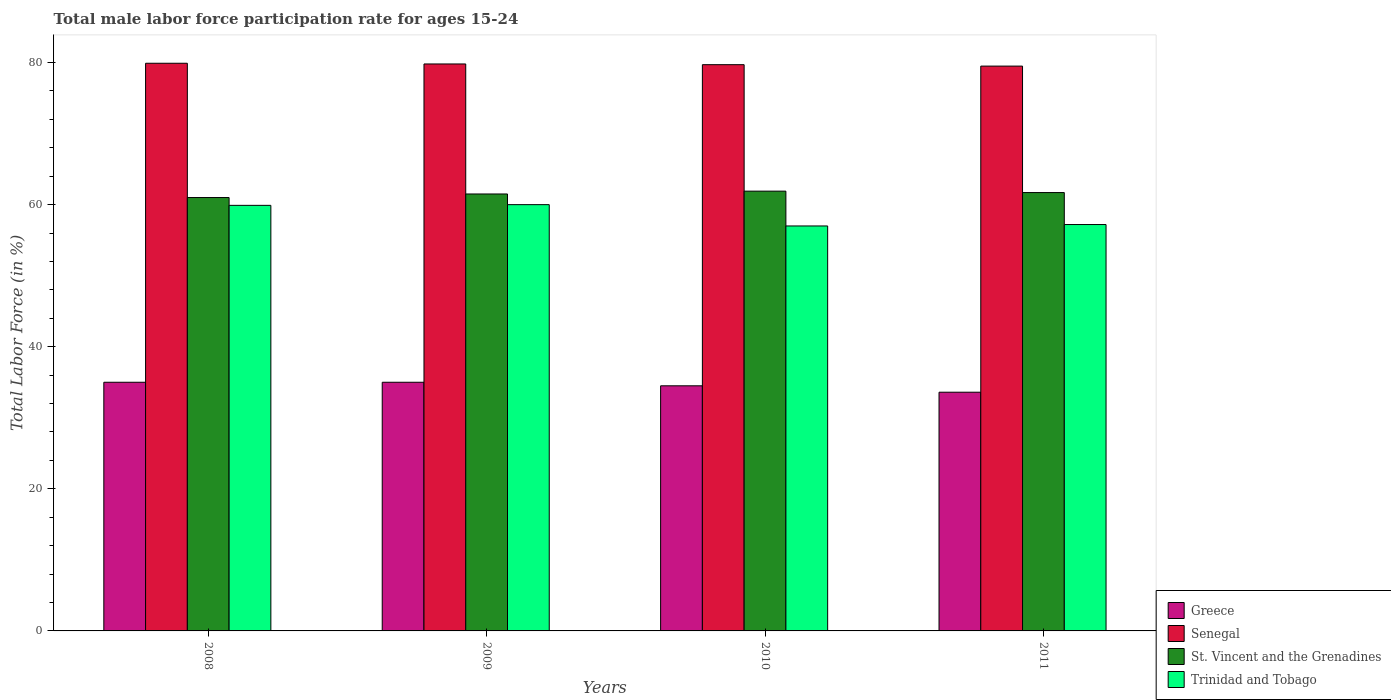How many different coloured bars are there?
Give a very brief answer. 4. Are the number of bars per tick equal to the number of legend labels?
Make the answer very short. Yes. How many bars are there on the 3rd tick from the left?
Ensure brevity in your answer.  4. What is the male labor force participation rate in St. Vincent and the Grenadines in 2011?
Offer a terse response. 61.7. Across all years, what is the maximum male labor force participation rate in Trinidad and Tobago?
Keep it short and to the point. 60. In which year was the male labor force participation rate in Trinidad and Tobago maximum?
Give a very brief answer. 2009. What is the total male labor force participation rate in Senegal in the graph?
Your answer should be very brief. 318.9. What is the difference between the male labor force participation rate in Senegal in 2010 and that in 2011?
Give a very brief answer. 0.2. What is the average male labor force participation rate in Trinidad and Tobago per year?
Ensure brevity in your answer.  58.53. In how many years, is the male labor force participation rate in St. Vincent and the Grenadines greater than 76 %?
Your answer should be very brief. 0. What is the ratio of the male labor force participation rate in Trinidad and Tobago in 2010 to that in 2011?
Give a very brief answer. 1. What is the difference between the highest and the second highest male labor force participation rate in Trinidad and Tobago?
Make the answer very short. 0.1. What is the difference between the highest and the lowest male labor force participation rate in Greece?
Ensure brevity in your answer.  1.4. In how many years, is the male labor force participation rate in St. Vincent and the Grenadines greater than the average male labor force participation rate in St. Vincent and the Grenadines taken over all years?
Your answer should be very brief. 2. Is the sum of the male labor force participation rate in Trinidad and Tobago in 2008 and 2009 greater than the maximum male labor force participation rate in Greece across all years?
Provide a succinct answer. Yes. Is it the case that in every year, the sum of the male labor force participation rate in St. Vincent and the Grenadines and male labor force participation rate in Senegal is greater than the sum of male labor force participation rate in Trinidad and Tobago and male labor force participation rate in Greece?
Provide a short and direct response. Yes. What does the 3rd bar from the left in 2009 represents?
Your answer should be very brief. St. Vincent and the Grenadines. What does the 1st bar from the right in 2010 represents?
Make the answer very short. Trinidad and Tobago. Is it the case that in every year, the sum of the male labor force participation rate in Senegal and male labor force participation rate in Greece is greater than the male labor force participation rate in St. Vincent and the Grenadines?
Offer a very short reply. Yes. How many bars are there?
Provide a succinct answer. 16. How many years are there in the graph?
Your answer should be very brief. 4. What is the difference between two consecutive major ticks on the Y-axis?
Offer a terse response. 20. What is the title of the graph?
Offer a terse response. Total male labor force participation rate for ages 15-24. What is the label or title of the Y-axis?
Provide a succinct answer. Total Labor Force (in %). What is the Total Labor Force (in %) of Greece in 2008?
Your answer should be very brief. 35. What is the Total Labor Force (in %) of Senegal in 2008?
Provide a succinct answer. 79.9. What is the Total Labor Force (in %) in St. Vincent and the Grenadines in 2008?
Keep it short and to the point. 61. What is the Total Labor Force (in %) in Trinidad and Tobago in 2008?
Make the answer very short. 59.9. What is the Total Labor Force (in %) in Senegal in 2009?
Your answer should be compact. 79.8. What is the Total Labor Force (in %) in St. Vincent and the Grenadines in 2009?
Ensure brevity in your answer.  61.5. What is the Total Labor Force (in %) of Greece in 2010?
Give a very brief answer. 34.5. What is the Total Labor Force (in %) in Senegal in 2010?
Make the answer very short. 79.7. What is the Total Labor Force (in %) of St. Vincent and the Grenadines in 2010?
Offer a terse response. 61.9. What is the Total Labor Force (in %) of Greece in 2011?
Offer a terse response. 33.6. What is the Total Labor Force (in %) of Senegal in 2011?
Offer a very short reply. 79.5. What is the Total Labor Force (in %) of St. Vincent and the Grenadines in 2011?
Your answer should be compact. 61.7. What is the Total Labor Force (in %) in Trinidad and Tobago in 2011?
Make the answer very short. 57.2. Across all years, what is the maximum Total Labor Force (in %) in Greece?
Provide a succinct answer. 35. Across all years, what is the maximum Total Labor Force (in %) of Senegal?
Your response must be concise. 79.9. Across all years, what is the maximum Total Labor Force (in %) in St. Vincent and the Grenadines?
Give a very brief answer. 61.9. Across all years, what is the minimum Total Labor Force (in %) in Greece?
Give a very brief answer. 33.6. Across all years, what is the minimum Total Labor Force (in %) in Senegal?
Offer a terse response. 79.5. Across all years, what is the minimum Total Labor Force (in %) in Trinidad and Tobago?
Give a very brief answer. 57. What is the total Total Labor Force (in %) in Greece in the graph?
Offer a terse response. 138.1. What is the total Total Labor Force (in %) in Senegal in the graph?
Provide a succinct answer. 318.9. What is the total Total Labor Force (in %) in St. Vincent and the Grenadines in the graph?
Provide a short and direct response. 246.1. What is the total Total Labor Force (in %) of Trinidad and Tobago in the graph?
Offer a very short reply. 234.1. What is the difference between the Total Labor Force (in %) in Greece in 2008 and that in 2009?
Keep it short and to the point. 0. What is the difference between the Total Labor Force (in %) of St. Vincent and the Grenadines in 2008 and that in 2009?
Offer a very short reply. -0.5. What is the difference between the Total Labor Force (in %) in Trinidad and Tobago in 2008 and that in 2009?
Your response must be concise. -0.1. What is the difference between the Total Labor Force (in %) of Greece in 2008 and that in 2010?
Keep it short and to the point. 0.5. What is the difference between the Total Labor Force (in %) of Senegal in 2008 and that in 2010?
Offer a terse response. 0.2. What is the difference between the Total Labor Force (in %) of St. Vincent and the Grenadines in 2008 and that in 2010?
Keep it short and to the point. -0.9. What is the difference between the Total Labor Force (in %) of Greece in 2008 and that in 2011?
Your response must be concise. 1.4. What is the difference between the Total Labor Force (in %) in Senegal in 2008 and that in 2011?
Provide a succinct answer. 0.4. What is the difference between the Total Labor Force (in %) of St. Vincent and the Grenadines in 2008 and that in 2011?
Your answer should be very brief. -0.7. What is the difference between the Total Labor Force (in %) in Greece in 2009 and that in 2010?
Make the answer very short. 0.5. What is the difference between the Total Labor Force (in %) in Greece in 2009 and that in 2011?
Make the answer very short. 1.4. What is the difference between the Total Labor Force (in %) in Trinidad and Tobago in 2009 and that in 2011?
Make the answer very short. 2.8. What is the difference between the Total Labor Force (in %) in Senegal in 2010 and that in 2011?
Provide a succinct answer. 0.2. What is the difference between the Total Labor Force (in %) in Trinidad and Tobago in 2010 and that in 2011?
Your answer should be very brief. -0.2. What is the difference between the Total Labor Force (in %) in Greece in 2008 and the Total Labor Force (in %) in Senegal in 2009?
Your response must be concise. -44.8. What is the difference between the Total Labor Force (in %) in Greece in 2008 and the Total Labor Force (in %) in St. Vincent and the Grenadines in 2009?
Provide a succinct answer. -26.5. What is the difference between the Total Labor Force (in %) of Greece in 2008 and the Total Labor Force (in %) of Trinidad and Tobago in 2009?
Offer a terse response. -25. What is the difference between the Total Labor Force (in %) of Greece in 2008 and the Total Labor Force (in %) of Senegal in 2010?
Give a very brief answer. -44.7. What is the difference between the Total Labor Force (in %) of Greece in 2008 and the Total Labor Force (in %) of St. Vincent and the Grenadines in 2010?
Your response must be concise. -26.9. What is the difference between the Total Labor Force (in %) of Senegal in 2008 and the Total Labor Force (in %) of St. Vincent and the Grenadines in 2010?
Keep it short and to the point. 18. What is the difference between the Total Labor Force (in %) of Senegal in 2008 and the Total Labor Force (in %) of Trinidad and Tobago in 2010?
Provide a short and direct response. 22.9. What is the difference between the Total Labor Force (in %) of St. Vincent and the Grenadines in 2008 and the Total Labor Force (in %) of Trinidad and Tobago in 2010?
Offer a very short reply. 4. What is the difference between the Total Labor Force (in %) of Greece in 2008 and the Total Labor Force (in %) of Senegal in 2011?
Your answer should be very brief. -44.5. What is the difference between the Total Labor Force (in %) of Greece in 2008 and the Total Labor Force (in %) of St. Vincent and the Grenadines in 2011?
Your answer should be compact. -26.7. What is the difference between the Total Labor Force (in %) of Greece in 2008 and the Total Labor Force (in %) of Trinidad and Tobago in 2011?
Give a very brief answer. -22.2. What is the difference between the Total Labor Force (in %) of Senegal in 2008 and the Total Labor Force (in %) of Trinidad and Tobago in 2011?
Your answer should be very brief. 22.7. What is the difference between the Total Labor Force (in %) of St. Vincent and the Grenadines in 2008 and the Total Labor Force (in %) of Trinidad and Tobago in 2011?
Provide a short and direct response. 3.8. What is the difference between the Total Labor Force (in %) of Greece in 2009 and the Total Labor Force (in %) of Senegal in 2010?
Your answer should be compact. -44.7. What is the difference between the Total Labor Force (in %) of Greece in 2009 and the Total Labor Force (in %) of St. Vincent and the Grenadines in 2010?
Your answer should be compact. -26.9. What is the difference between the Total Labor Force (in %) in Senegal in 2009 and the Total Labor Force (in %) in St. Vincent and the Grenadines in 2010?
Make the answer very short. 17.9. What is the difference between the Total Labor Force (in %) of Senegal in 2009 and the Total Labor Force (in %) of Trinidad and Tobago in 2010?
Offer a terse response. 22.8. What is the difference between the Total Labor Force (in %) of Greece in 2009 and the Total Labor Force (in %) of Senegal in 2011?
Offer a terse response. -44.5. What is the difference between the Total Labor Force (in %) of Greece in 2009 and the Total Labor Force (in %) of St. Vincent and the Grenadines in 2011?
Make the answer very short. -26.7. What is the difference between the Total Labor Force (in %) in Greece in 2009 and the Total Labor Force (in %) in Trinidad and Tobago in 2011?
Provide a succinct answer. -22.2. What is the difference between the Total Labor Force (in %) in Senegal in 2009 and the Total Labor Force (in %) in Trinidad and Tobago in 2011?
Keep it short and to the point. 22.6. What is the difference between the Total Labor Force (in %) of St. Vincent and the Grenadines in 2009 and the Total Labor Force (in %) of Trinidad and Tobago in 2011?
Provide a short and direct response. 4.3. What is the difference between the Total Labor Force (in %) of Greece in 2010 and the Total Labor Force (in %) of Senegal in 2011?
Offer a terse response. -45. What is the difference between the Total Labor Force (in %) in Greece in 2010 and the Total Labor Force (in %) in St. Vincent and the Grenadines in 2011?
Provide a short and direct response. -27.2. What is the difference between the Total Labor Force (in %) of Greece in 2010 and the Total Labor Force (in %) of Trinidad and Tobago in 2011?
Keep it short and to the point. -22.7. What is the difference between the Total Labor Force (in %) in Senegal in 2010 and the Total Labor Force (in %) in St. Vincent and the Grenadines in 2011?
Make the answer very short. 18. What is the difference between the Total Labor Force (in %) of Senegal in 2010 and the Total Labor Force (in %) of Trinidad and Tobago in 2011?
Keep it short and to the point. 22.5. What is the difference between the Total Labor Force (in %) of St. Vincent and the Grenadines in 2010 and the Total Labor Force (in %) of Trinidad and Tobago in 2011?
Your response must be concise. 4.7. What is the average Total Labor Force (in %) in Greece per year?
Your answer should be very brief. 34.52. What is the average Total Labor Force (in %) in Senegal per year?
Your answer should be compact. 79.72. What is the average Total Labor Force (in %) in St. Vincent and the Grenadines per year?
Offer a very short reply. 61.52. What is the average Total Labor Force (in %) in Trinidad and Tobago per year?
Give a very brief answer. 58.52. In the year 2008, what is the difference between the Total Labor Force (in %) of Greece and Total Labor Force (in %) of Senegal?
Keep it short and to the point. -44.9. In the year 2008, what is the difference between the Total Labor Force (in %) of Greece and Total Labor Force (in %) of Trinidad and Tobago?
Offer a very short reply. -24.9. In the year 2008, what is the difference between the Total Labor Force (in %) of Senegal and Total Labor Force (in %) of Trinidad and Tobago?
Give a very brief answer. 20. In the year 2009, what is the difference between the Total Labor Force (in %) of Greece and Total Labor Force (in %) of Senegal?
Ensure brevity in your answer.  -44.8. In the year 2009, what is the difference between the Total Labor Force (in %) of Greece and Total Labor Force (in %) of St. Vincent and the Grenadines?
Keep it short and to the point. -26.5. In the year 2009, what is the difference between the Total Labor Force (in %) of Greece and Total Labor Force (in %) of Trinidad and Tobago?
Your answer should be very brief. -25. In the year 2009, what is the difference between the Total Labor Force (in %) in Senegal and Total Labor Force (in %) in St. Vincent and the Grenadines?
Your answer should be compact. 18.3. In the year 2009, what is the difference between the Total Labor Force (in %) of Senegal and Total Labor Force (in %) of Trinidad and Tobago?
Give a very brief answer. 19.8. In the year 2010, what is the difference between the Total Labor Force (in %) of Greece and Total Labor Force (in %) of Senegal?
Provide a short and direct response. -45.2. In the year 2010, what is the difference between the Total Labor Force (in %) of Greece and Total Labor Force (in %) of St. Vincent and the Grenadines?
Make the answer very short. -27.4. In the year 2010, what is the difference between the Total Labor Force (in %) in Greece and Total Labor Force (in %) in Trinidad and Tobago?
Your answer should be compact. -22.5. In the year 2010, what is the difference between the Total Labor Force (in %) in Senegal and Total Labor Force (in %) in St. Vincent and the Grenadines?
Your answer should be very brief. 17.8. In the year 2010, what is the difference between the Total Labor Force (in %) in Senegal and Total Labor Force (in %) in Trinidad and Tobago?
Offer a terse response. 22.7. In the year 2010, what is the difference between the Total Labor Force (in %) of St. Vincent and the Grenadines and Total Labor Force (in %) of Trinidad and Tobago?
Offer a terse response. 4.9. In the year 2011, what is the difference between the Total Labor Force (in %) in Greece and Total Labor Force (in %) in Senegal?
Offer a terse response. -45.9. In the year 2011, what is the difference between the Total Labor Force (in %) in Greece and Total Labor Force (in %) in St. Vincent and the Grenadines?
Provide a succinct answer. -28.1. In the year 2011, what is the difference between the Total Labor Force (in %) in Greece and Total Labor Force (in %) in Trinidad and Tobago?
Offer a very short reply. -23.6. In the year 2011, what is the difference between the Total Labor Force (in %) in Senegal and Total Labor Force (in %) in Trinidad and Tobago?
Offer a terse response. 22.3. What is the ratio of the Total Labor Force (in %) of Greece in 2008 to that in 2009?
Offer a very short reply. 1. What is the ratio of the Total Labor Force (in %) of Senegal in 2008 to that in 2009?
Your answer should be compact. 1. What is the ratio of the Total Labor Force (in %) in St. Vincent and the Grenadines in 2008 to that in 2009?
Your answer should be compact. 0.99. What is the ratio of the Total Labor Force (in %) of Greece in 2008 to that in 2010?
Keep it short and to the point. 1.01. What is the ratio of the Total Labor Force (in %) of St. Vincent and the Grenadines in 2008 to that in 2010?
Give a very brief answer. 0.99. What is the ratio of the Total Labor Force (in %) in Trinidad and Tobago in 2008 to that in 2010?
Offer a very short reply. 1.05. What is the ratio of the Total Labor Force (in %) of Greece in 2008 to that in 2011?
Keep it short and to the point. 1.04. What is the ratio of the Total Labor Force (in %) of St. Vincent and the Grenadines in 2008 to that in 2011?
Make the answer very short. 0.99. What is the ratio of the Total Labor Force (in %) of Trinidad and Tobago in 2008 to that in 2011?
Provide a short and direct response. 1.05. What is the ratio of the Total Labor Force (in %) of Greece in 2009 to that in 2010?
Give a very brief answer. 1.01. What is the ratio of the Total Labor Force (in %) in Senegal in 2009 to that in 2010?
Provide a succinct answer. 1. What is the ratio of the Total Labor Force (in %) of Trinidad and Tobago in 2009 to that in 2010?
Your response must be concise. 1.05. What is the ratio of the Total Labor Force (in %) of Greece in 2009 to that in 2011?
Make the answer very short. 1.04. What is the ratio of the Total Labor Force (in %) of St. Vincent and the Grenadines in 2009 to that in 2011?
Offer a very short reply. 1. What is the ratio of the Total Labor Force (in %) of Trinidad and Tobago in 2009 to that in 2011?
Ensure brevity in your answer.  1.05. What is the ratio of the Total Labor Force (in %) of Greece in 2010 to that in 2011?
Give a very brief answer. 1.03. What is the ratio of the Total Labor Force (in %) in St. Vincent and the Grenadines in 2010 to that in 2011?
Make the answer very short. 1. What is the ratio of the Total Labor Force (in %) of Trinidad and Tobago in 2010 to that in 2011?
Your answer should be compact. 1. What is the difference between the highest and the second highest Total Labor Force (in %) in Senegal?
Offer a very short reply. 0.1. What is the difference between the highest and the second highest Total Labor Force (in %) in St. Vincent and the Grenadines?
Offer a terse response. 0.2. What is the difference between the highest and the second highest Total Labor Force (in %) in Trinidad and Tobago?
Give a very brief answer. 0.1. What is the difference between the highest and the lowest Total Labor Force (in %) of Senegal?
Provide a short and direct response. 0.4. What is the difference between the highest and the lowest Total Labor Force (in %) of St. Vincent and the Grenadines?
Keep it short and to the point. 0.9. What is the difference between the highest and the lowest Total Labor Force (in %) in Trinidad and Tobago?
Offer a terse response. 3. 